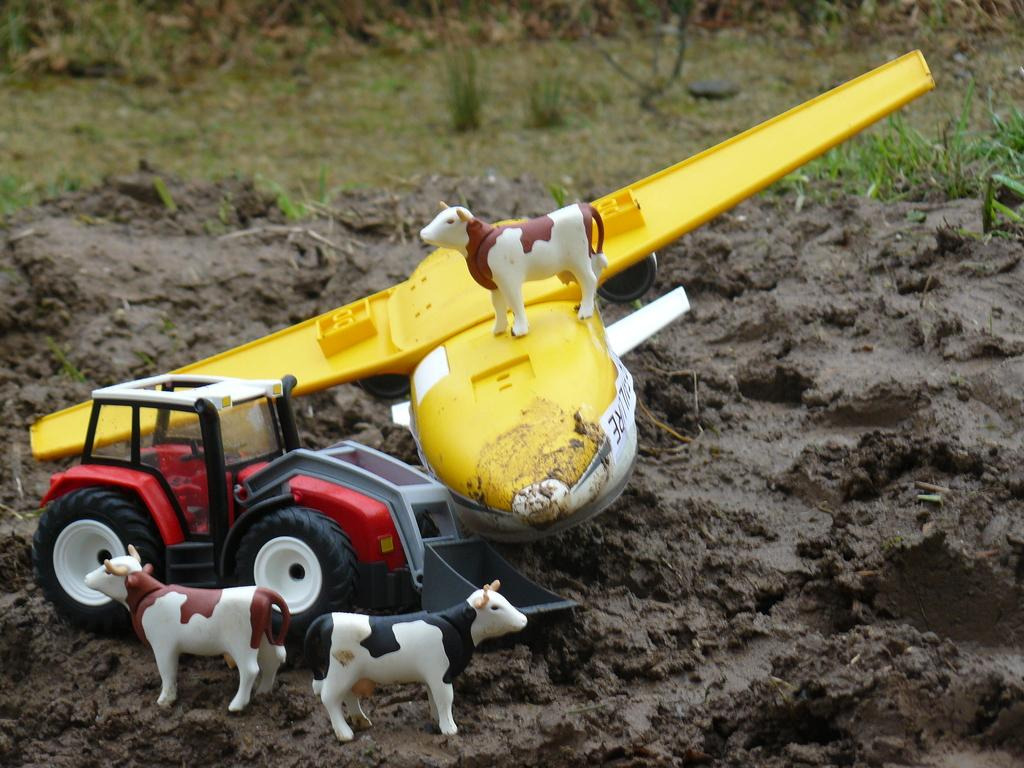What animals are present in the image? There are cows in the image. What type of vehicle can be seen in the image? There is a tractor in the image. Where is the tractor located in relation to the soil? The tractor is on the surface of the soil. What type of vegetation is visible in the background of the image? There is: There is grass visible in the background of the image. Can you see any giants holding a gun in the image? There are no giants or guns present in the image. Is there a chair visible in the image? There is no chair visible in the image. 